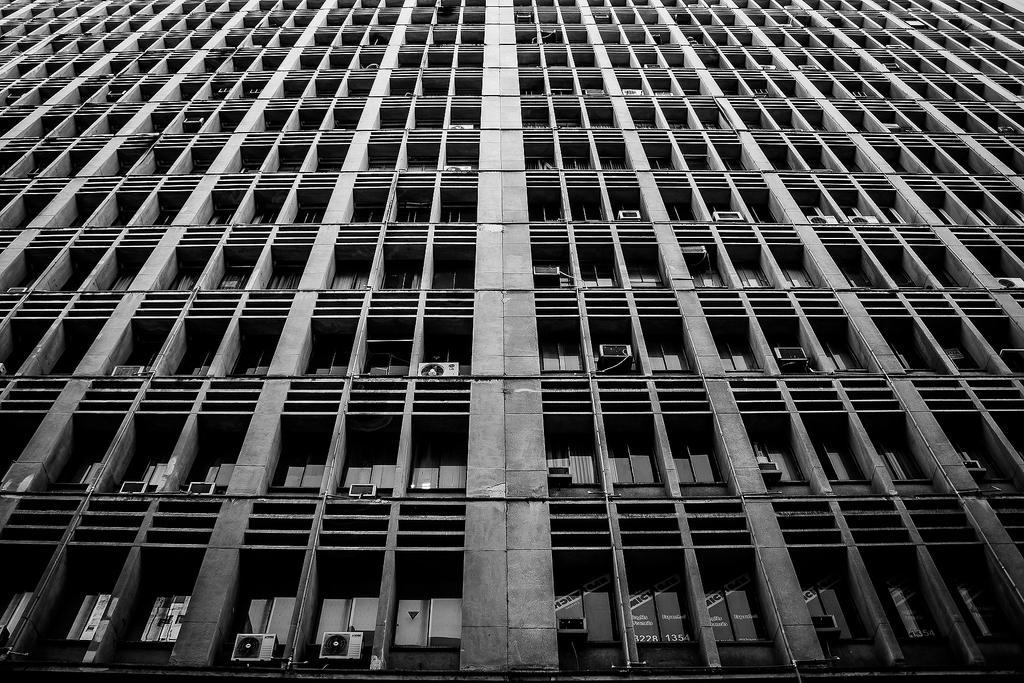Describe this image in one or two sentences. In this image I can see a building along with the windows and some air conditioners. 